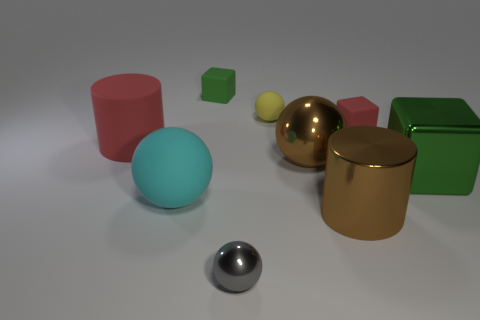Subtract all purple spheres. Subtract all purple blocks. How many spheres are left? 4 Add 1 cyan matte things. How many objects exist? 10 Subtract all balls. How many objects are left? 5 Add 3 large brown things. How many large brown things are left? 5 Add 8 tiny cyan shiny balls. How many tiny cyan shiny balls exist? 8 Subtract 1 red cylinders. How many objects are left? 8 Subtract all green metallic cubes. Subtract all green matte objects. How many objects are left? 7 